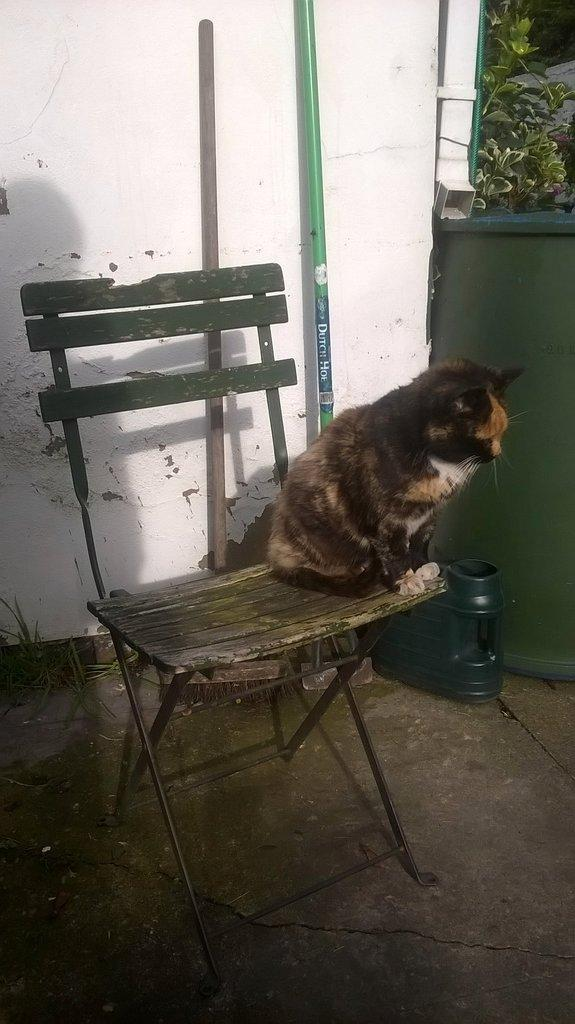Where was the image taken? The image was taken outside of a house. What furniture is visible in the image? There is a chair in the image. What is sitting on the chair? A cat is sitting on the chair. What can be seen behind the chair? There is a white color wall and trees in the background. What other object is present in the background? There is a can in the background. What type of yarn is the cat using to knit a scarf in the image? There is no yarn or knitting activity present in the image; the cat is simply sitting on the chair. 